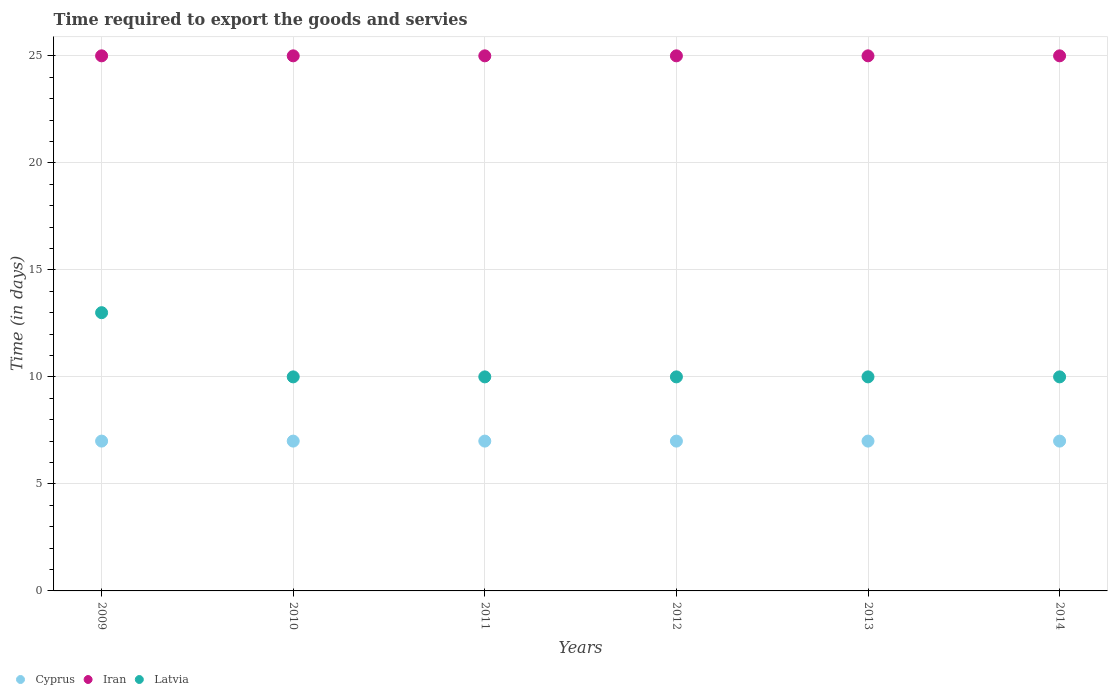How many different coloured dotlines are there?
Ensure brevity in your answer.  3. Is the number of dotlines equal to the number of legend labels?
Your response must be concise. Yes. What is the number of days required to export the goods and services in Latvia in 2010?
Provide a short and direct response. 10. Across all years, what is the maximum number of days required to export the goods and services in Iran?
Provide a succinct answer. 25. Across all years, what is the minimum number of days required to export the goods and services in Latvia?
Offer a terse response. 10. In which year was the number of days required to export the goods and services in Latvia maximum?
Offer a very short reply. 2009. In which year was the number of days required to export the goods and services in Iran minimum?
Ensure brevity in your answer.  2009. What is the difference between the number of days required to export the goods and services in Latvia in 2009 and that in 2013?
Give a very brief answer. 3. What is the difference between the number of days required to export the goods and services in Latvia in 2010 and the number of days required to export the goods and services in Iran in 2012?
Make the answer very short. -15. What is the average number of days required to export the goods and services in Cyprus per year?
Your response must be concise. 7. In the year 2011, what is the difference between the number of days required to export the goods and services in Iran and number of days required to export the goods and services in Cyprus?
Your answer should be compact. 18. Is the number of days required to export the goods and services in Latvia in 2010 less than that in 2014?
Keep it short and to the point. No. Is the difference between the number of days required to export the goods and services in Iran in 2010 and 2014 greater than the difference between the number of days required to export the goods and services in Cyprus in 2010 and 2014?
Make the answer very short. No. What is the difference between the highest and the second highest number of days required to export the goods and services in Latvia?
Provide a short and direct response. 3. What is the difference between the highest and the lowest number of days required to export the goods and services in Cyprus?
Keep it short and to the point. 0. In how many years, is the number of days required to export the goods and services in Latvia greater than the average number of days required to export the goods and services in Latvia taken over all years?
Your answer should be very brief. 1. Is the sum of the number of days required to export the goods and services in Iran in 2009 and 2013 greater than the maximum number of days required to export the goods and services in Cyprus across all years?
Make the answer very short. Yes. Is it the case that in every year, the sum of the number of days required to export the goods and services in Cyprus and number of days required to export the goods and services in Iran  is greater than the number of days required to export the goods and services in Latvia?
Keep it short and to the point. Yes. Is the number of days required to export the goods and services in Latvia strictly less than the number of days required to export the goods and services in Iran over the years?
Your answer should be compact. Yes. Does the graph contain any zero values?
Ensure brevity in your answer.  No. Does the graph contain grids?
Keep it short and to the point. Yes. Where does the legend appear in the graph?
Your answer should be compact. Bottom left. How many legend labels are there?
Your answer should be compact. 3. How are the legend labels stacked?
Your answer should be compact. Horizontal. What is the title of the graph?
Offer a very short reply. Time required to export the goods and servies. Does "Botswana" appear as one of the legend labels in the graph?
Ensure brevity in your answer.  No. What is the label or title of the X-axis?
Give a very brief answer. Years. What is the label or title of the Y-axis?
Keep it short and to the point. Time (in days). What is the Time (in days) in Iran in 2009?
Ensure brevity in your answer.  25. What is the Time (in days) of Latvia in 2009?
Make the answer very short. 13. What is the Time (in days) in Iran in 2010?
Ensure brevity in your answer.  25. What is the Time (in days) in Iran in 2011?
Offer a terse response. 25. What is the Time (in days) in Cyprus in 2012?
Offer a very short reply. 7. What is the Time (in days) of Cyprus in 2013?
Your response must be concise. 7. What is the Time (in days) of Cyprus in 2014?
Provide a short and direct response. 7. What is the Time (in days) of Iran in 2014?
Offer a terse response. 25. Across all years, what is the maximum Time (in days) in Latvia?
Your response must be concise. 13. Across all years, what is the minimum Time (in days) of Cyprus?
Offer a very short reply. 7. What is the total Time (in days) of Cyprus in the graph?
Give a very brief answer. 42. What is the total Time (in days) of Iran in the graph?
Your response must be concise. 150. What is the total Time (in days) in Latvia in the graph?
Keep it short and to the point. 63. What is the difference between the Time (in days) in Cyprus in 2009 and that in 2011?
Keep it short and to the point. 0. What is the difference between the Time (in days) of Iran in 2009 and that in 2011?
Your answer should be compact. 0. What is the difference between the Time (in days) of Latvia in 2009 and that in 2011?
Offer a very short reply. 3. What is the difference between the Time (in days) of Cyprus in 2009 and that in 2012?
Your response must be concise. 0. What is the difference between the Time (in days) in Iran in 2009 and that in 2012?
Offer a very short reply. 0. What is the difference between the Time (in days) of Latvia in 2009 and that in 2012?
Your answer should be compact. 3. What is the difference between the Time (in days) in Iran in 2009 and that in 2013?
Your answer should be very brief. 0. What is the difference between the Time (in days) in Latvia in 2009 and that in 2014?
Provide a short and direct response. 3. What is the difference between the Time (in days) in Latvia in 2010 and that in 2011?
Provide a short and direct response. 0. What is the difference between the Time (in days) in Cyprus in 2010 and that in 2012?
Offer a very short reply. 0. What is the difference between the Time (in days) of Iran in 2010 and that in 2012?
Make the answer very short. 0. What is the difference between the Time (in days) in Latvia in 2010 and that in 2012?
Your response must be concise. 0. What is the difference between the Time (in days) of Iran in 2010 and that in 2014?
Your answer should be compact. 0. What is the difference between the Time (in days) in Cyprus in 2011 and that in 2012?
Your answer should be compact. 0. What is the difference between the Time (in days) in Latvia in 2011 and that in 2012?
Give a very brief answer. 0. What is the difference between the Time (in days) of Cyprus in 2011 and that in 2013?
Offer a very short reply. 0. What is the difference between the Time (in days) in Cyprus in 2011 and that in 2014?
Ensure brevity in your answer.  0. What is the difference between the Time (in days) of Iran in 2012 and that in 2013?
Your answer should be compact. 0. What is the difference between the Time (in days) of Latvia in 2012 and that in 2013?
Ensure brevity in your answer.  0. What is the difference between the Time (in days) in Cyprus in 2012 and that in 2014?
Your response must be concise. 0. What is the difference between the Time (in days) in Latvia in 2012 and that in 2014?
Provide a succinct answer. 0. What is the difference between the Time (in days) in Cyprus in 2009 and the Time (in days) in Latvia in 2010?
Ensure brevity in your answer.  -3. What is the difference between the Time (in days) of Iran in 2009 and the Time (in days) of Latvia in 2010?
Your answer should be very brief. 15. What is the difference between the Time (in days) in Cyprus in 2009 and the Time (in days) in Latvia in 2011?
Your answer should be compact. -3. What is the difference between the Time (in days) in Iran in 2009 and the Time (in days) in Latvia in 2011?
Offer a very short reply. 15. What is the difference between the Time (in days) of Cyprus in 2009 and the Time (in days) of Iran in 2012?
Your answer should be very brief. -18. What is the difference between the Time (in days) in Cyprus in 2009 and the Time (in days) in Latvia in 2012?
Your answer should be compact. -3. What is the difference between the Time (in days) in Cyprus in 2009 and the Time (in days) in Iran in 2013?
Keep it short and to the point. -18. What is the difference between the Time (in days) of Cyprus in 2009 and the Time (in days) of Iran in 2014?
Your answer should be very brief. -18. What is the difference between the Time (in days) in Cyprus in 2009 and the Time (in days) in Latvia in 2014?
Provide a succinct answer. -3. What is the difference between the Time (in days) of Iran in 2009 and the Time (in days) of Latvia in 2014?
Offer a very short reply. 15. What is the difference between the Time (in days) of Cyprus in 2010 and the Time (in days) of Iran in 2011?
Provide a short and direct response. -18. What is the difference between the Time (in days) of Cyprus in 2010 and the Time (in days) of Latvia in 2011?
Your response must be concise. -3. What is the difference between the Time (in days) in Cyprus in 2010 and the Time (in days) in Iran in 2012?
Make the answer very short. -18. What is the difference between the Time (in days) of Cyprus in 2010 and the Time (in days) of Latvia in 2012?
Ensure brevity in your answer.  -3. What is the difference between the Time (in days) of Cyprus in 2010 and the Time (in days) of Iran in 2013?
Provide a short and direct response. -18. What is the difference between the Time (in days) in Cyprus in 2010 and the Time (in days) in Latvia in 2013?
Provide a short and direct response. -3. What is the difference between the Time (in days) of Iran in 2010 and the Time (in days) of Latvia in 2013?
Your answer should be very brief. 15. What is the difference between the Time (in days) in Cyprus in 2010 and the Time (in days) in Iran in 2014?
Make the answer very short. -18. What is the difference between the Time (in days) in Cyprus in 2011 and the Time (in days) in Latvia in 2012?
Ensure brevity in your answer.  -3. What is the difference between the Time (in days) in Cyprus in 2011 and the Time (in days) in Latvia in 2014?
Give a very brief answer. -3. What is the difference between the Time (in days) in Iran in 2011 and the Time (in days) in Latvia in 2014?
Make the answer very short. 15. What is the difference between the Time (in days) in Cyprus in 2012 and the Time (in days) in Latvia in 2013?
Give a very brief answer. -3. What is the difference between the Time (in days) of Iran in 2012 and the Time (in days) of Latvia in 2013?
Make the answer very short. 15. What is the difference between the Time (in days) in Cyprus in 2012 and the Time (in days) in Iran in 2014?
Keep it short and to the point. -18. What is the difference between the Time (in days) in Cyprus in 2012 and the Time (in days) in Latvia in 2014?
Provide a succinct answer. -3. What is the difference between the Time (in days) in Cyprus in 2013 and the Time (in days) in Latvia in 2014?
Offer a terse response. -3. What is the difference between the Time (in days) in Iran in 2013 and the Time (in days) in Latvia in 2014?
Provide a succinct answer. 15. What is the average Time (in days) of Latvia per year?
Keep it short and to the point. 10.5. In the year 2009, what is the difference between the Time (in days) of Cyprus and Time (in days) of Iran?
Ensure brevity in your answer.  -18. In the year 2010, what is the difference between the Time (in days) in Cyprus and Time (in days) in Iran?
Provide a short and direct response. -18. In the year 2011, what is the difference between the Time (in days) of Iran and Time (in days) of Latvia?
Make the answer very short. 15. In the year 2012, what is the difference between the Time (in days) in Cyprus and Time (in days) in Iran?
Keep it short and to the point. -18. In the year 2012, what is the difference between the Time (in days) of Iran and Time (in days) of Latvia?
Offer a terse response. 15. In the year 2013, what is the difference between the Time (in days) of Cyprus and Time (in days) of Latvia?
Provide a short and direct response. -3. What is the ratio of the Time (in days) in Cyprus in 2009 to that in 2010?
Make the answer very short. 1. What is the ratio of the Time (in days) in Iran in 2009 to that in 2010?
Make the answer very short. 1. What is the ratio of the Time (in days) in Cyprus in 2009 to that in 2011?
Provide a short and direct response. 1. What is the ratio of the Time (in days) in Iran in 2009 to that in 2011?
Your answer should be very brief. 1. What is the ratio of the Time (in days) of Latvia in 2009 to that in 2012?
Keep it short and to the point. 1.3. What is the ratio of the Time (in days) of Latvia in 2009 to that in 2014?
Make the answer very short. 1.3. What is the ratio of the Time (in days) of Cyprus in 2010 to that in 2011?
Your response must be concise. 1. What is the ratio of the Time (in days) in Cyprus in 2010 to that in 2012?
Your response must be concise. 1. What is the ratio of the Time (in days) in Cyprus in 2010 to that in 2013?
Your answer should be compact. 1. What is the ratio of the Time (in days) of Latvia in 2010 to that in 2013?
Your response must be concise. 1. What is the ratio of the Time (in days) in Latvia in 2010 to that in 2014?
Your response must be concise. 1. What is the ratio of the Time (in days) in Iran in 2011 to that in 2013?
Provide a succinct answer. 1. What is the ratio of the Time (in days) of Latvia in 2011 to that in 2013?
Your answer should be very brief. 1. What is the ratio of the Time (in days) in Cyprus in 2011 to that in 2014?
Offer a terse response. 1. What is the ratio of the Time (in days) of Iran in 2011 to that in 2014?
Make the answer very short. 1. What is the ratio of the Time (in days) of Cyprus in 2012 to that in 2013?
Offer a very short reply. 1. What is the ratio of the Time (in days) in Cyprus in 2012 to that in 2014?
Your response must be concise. 1. What is the ratio of the Time (in days) in Iran in 2012 to that in 2014?
Provide a succinct answer. 1. What is the ratio of the Time (in days) of Cyprus in 2013 to that in 2014?
Your answer should be compact. 1. What is the ratio of the Time (in days) in Latvia in 2013 to that in 2014?
Give a very brief answer. 1. What is the difference between the highest and the second highest Time (in days) of Cyprus?
Provide a succinct answer. 0. What is the difference between the highest and the second highest Time (in days) in Iran?
Your answer should be very brief. 0. What is the difference between the highest and the second highest Time (in days) of Latvia?
Your response must be concise. 3. What is the difference between the highest and the lowest Time (in days) of Cyprus?
Offer a terse response. 0. 